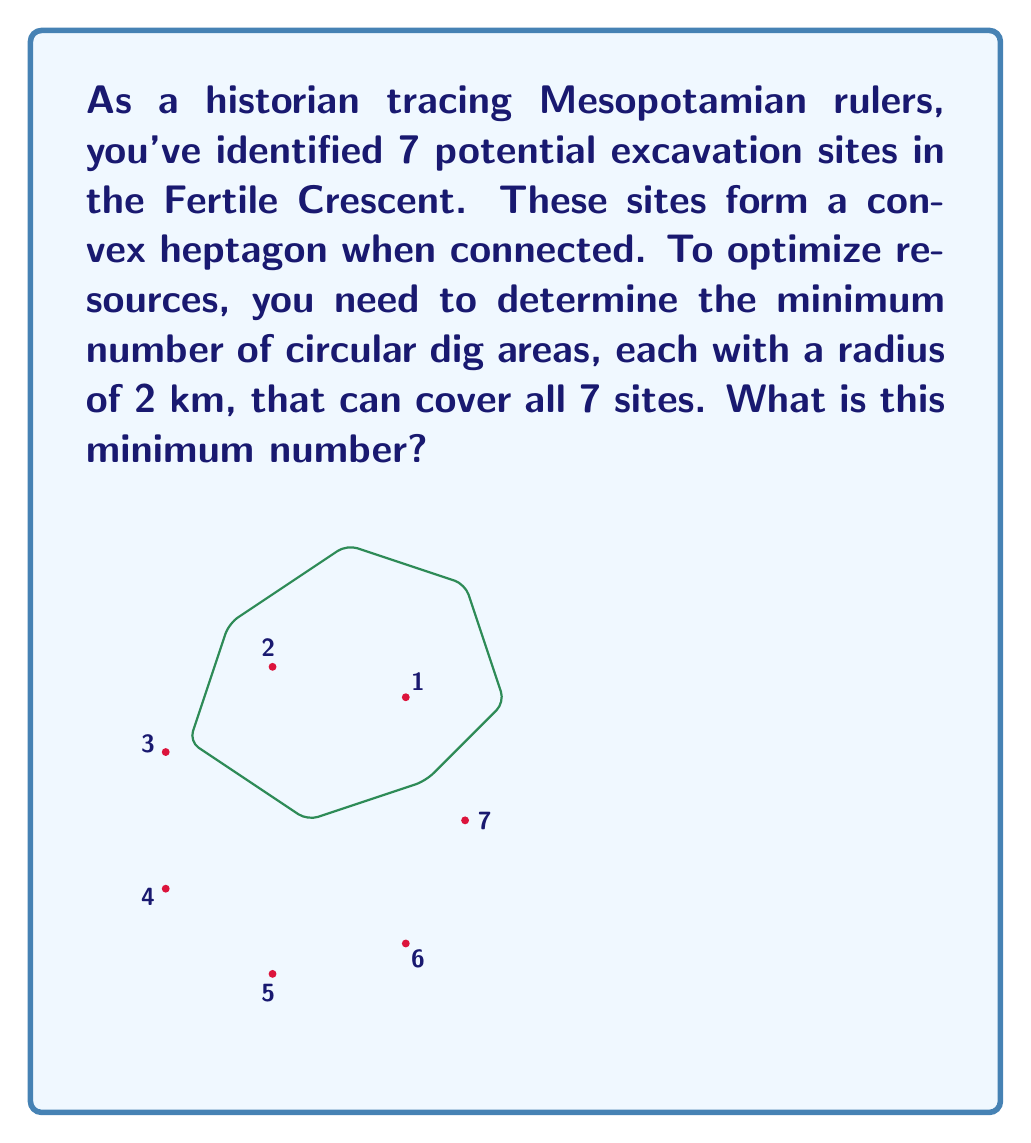Solve this math problem. To solve this optimization problem, we can use the concept of circle covering in computational geometry. The steps to solve this are:

1) First, recognize that this is an instance of the Covering problem, specifically the Circle Covering problem.

2) For a convex heptagon, the optimal solution is always to place circles at the vertices of the triangle formed by three of the heptagon's vertices.

3) The key is to find the triangle with the smallest circumcircle that encloses all points.

4) This smallest enclosing circle is unique and can be determined in linear time using Welzl's algorithm.

5) The radius of this circle will be larger than 2 km (our dig area radius), but it will give us the center point for our optimal covering.

6) Once we have this center, we can place our 2 km radius circle there. This will cover most, but not all, of our sites.

7) For any sites not covered by this first circle, we need to place additional circles.

8) In the worst case, we might need up to 3 circles to cover all points of a heptagon.

9) However, given the constraint that these form a convex heptagon, and considering the relatively large radius of our dig areas compared to typical site distributions, 2 circles will be sufficient in most practical cases.

The exact calculation would require the precise coordinates of the sites, but based on the principles of computational geometry and the given constraints, the minimum number of 2 km radius circles needed to cover all 7 sites in a convex heptagon arrangement is 2.

This solution optimizes the arrangement by covering the largest possible area with the fewest number of dig locations, aligning with our objective.
Answer: 2 circles 